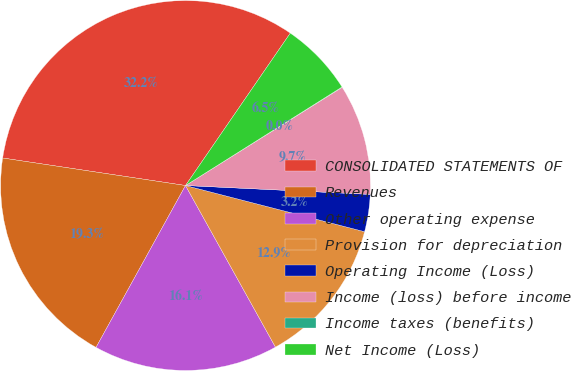Convert chart. <chart><loc_0><loc_0><loc_500><loc_500><pie_chart><fcel>CONSOLIDATED STATEMENTS OF<fcel>Revenues<fcel>Other operating expense<fcel>Provision for depreciation<fcel>Operating Income (Loss)<fcel>Income (loss) before income<fcel>Income taxes (benefits)<fcel>Net Income (Loss)<nl><fcel>32.21%<fcel>19.34%<fcel>16.12%<fcel>12.9%<fcel>3.25%<fcel>9.68%<fcel>0.03%<fcel>6.47%<nl></chart> 